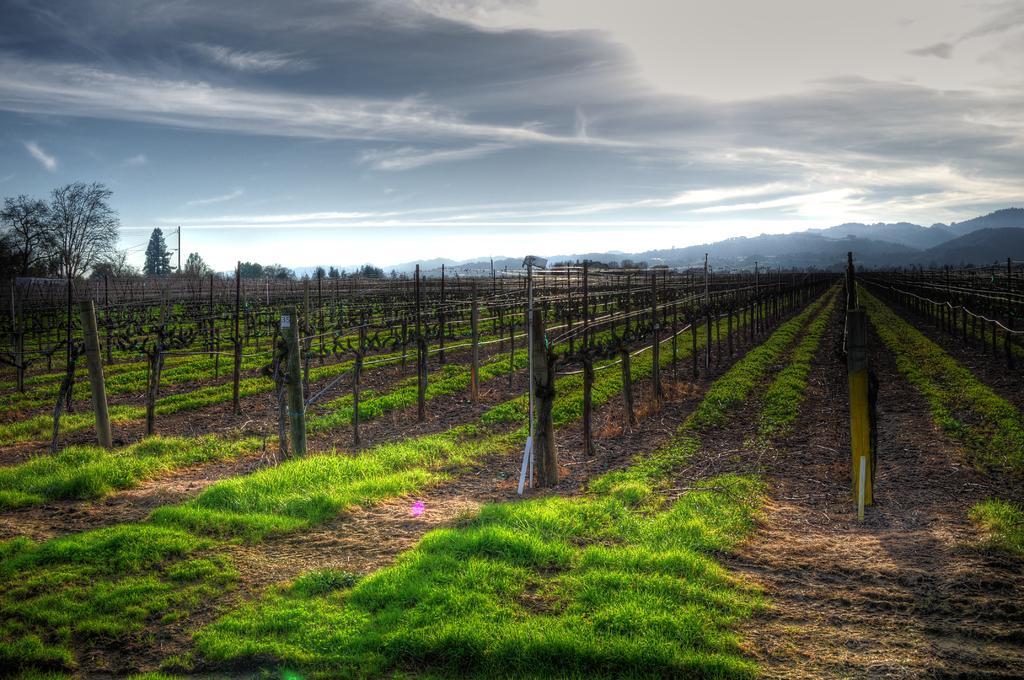Can you describe this image briefly? Here in this picture we can see the ground is fully covered with grass and in between that we can see number of moles present and we can see fencing covered through the poles and we can also see plants and trees present in the far and we can also see mountains in the far and we can see the sky is covered with clouds. 